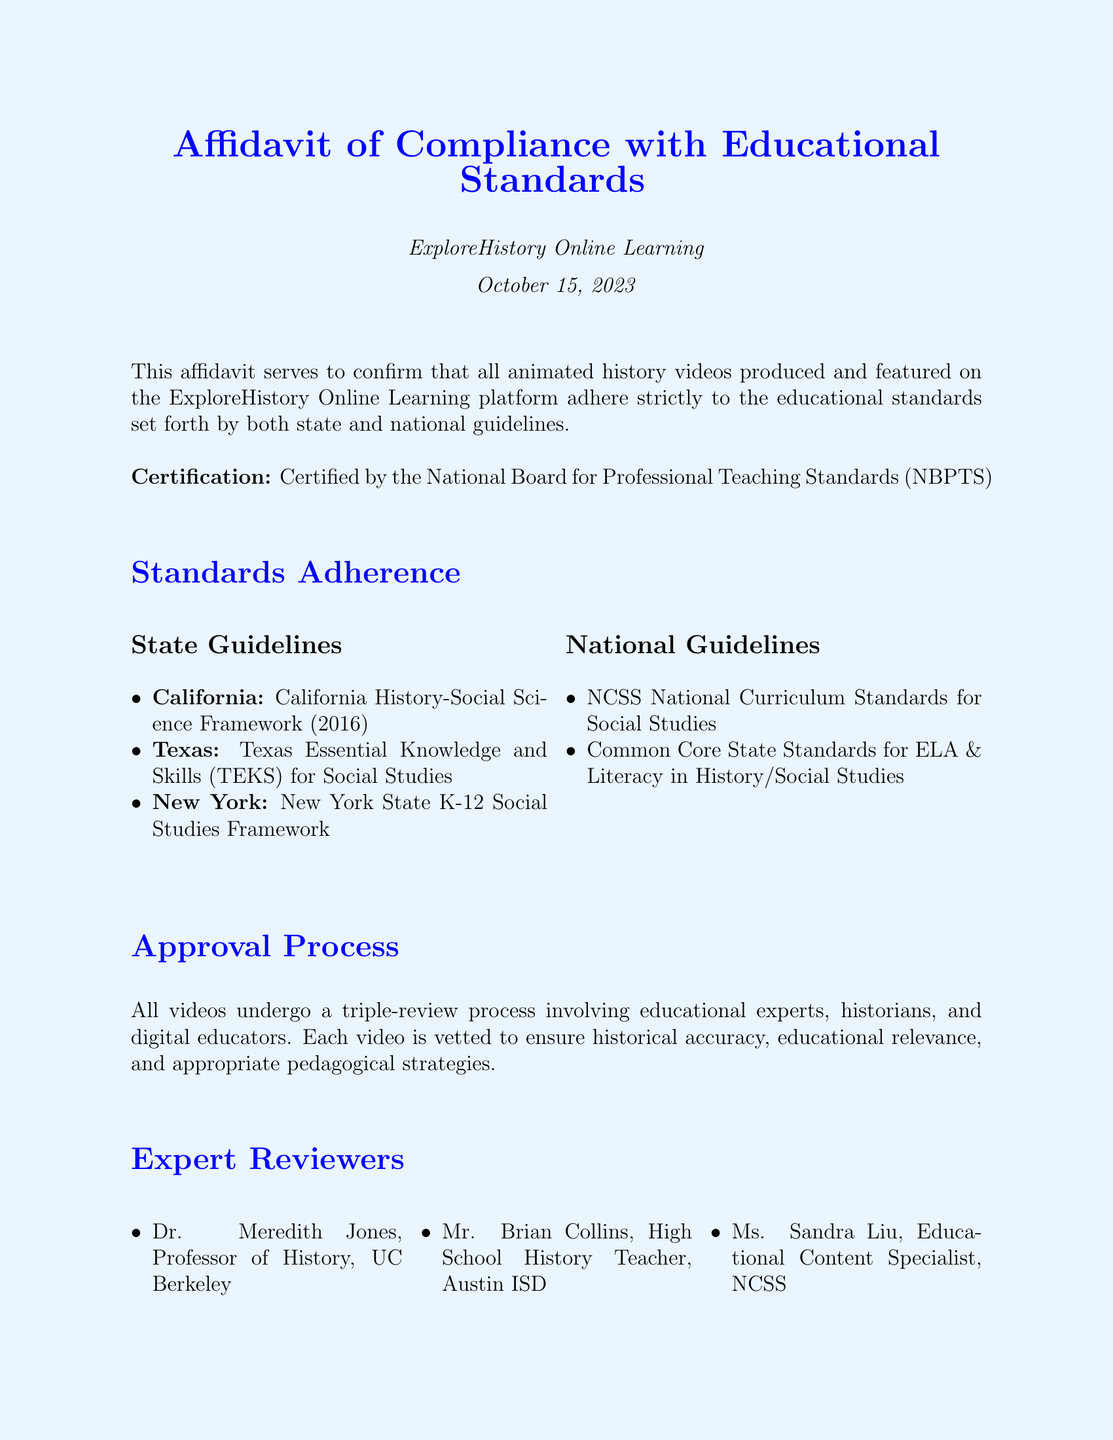What is the name of the online learning platform? The document explicitly states that the affidavit is for ExploreHistory Online Learning.
Answer: ExploreHistory Online Learning When was the affidavit signed? The document mentions the date of October 15, 2023.
Answer: October 15, 2023 Who certified the compliance with educational standards? The document indicates that it is certified by the National Board for Professional Teaching Standards (NBPTS).
Answer: National Board for Professional Teaching Standards What is the review process mentioned in the document? The document notes that all videos undergo a triple-review process involving educational experts, historians, and digital educators.
Answer: Triple-review process Who is the Chief Educational Officer? The document provides the name Jennifer Thompson as the Chief Educational Officer.
Answer: Jennifer Thompson Which state guidelines are mentioned? The document lists California History-Social Science Framework, Texas Essential Knowledge and Skills, and New York State K-12 Social Studies Framework as state guidelines.
Answer: California, Texas, New York What type of experts review the videos? The affidavit specifies that the videos are reviewed by educational experts, historians, and digital educators.
Answer: Educational experts, historians, digital educators What is included in the National Guidelines? The document mentions NCSS National Curriculum Standards for Social Studies and Common Core State Standards for ELA & Literacy in History/Social Studies.
Answer: NCSS standards, Common Core standards 